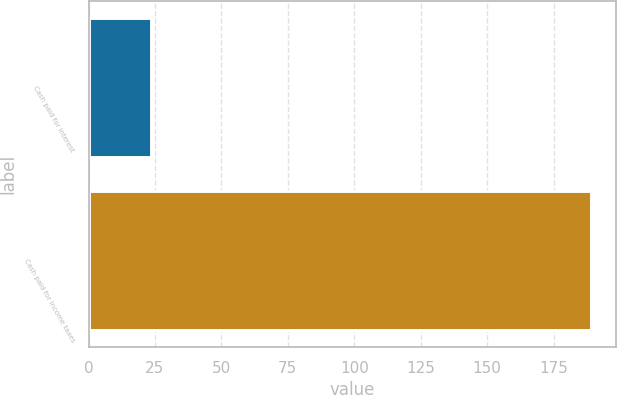Convert chart to OTSL. <chart><loc_0><loc_0><loc_500><loc_500><bar_chart><fcel>Cash paid for interest<fcel>Cash paid for income taxes<nl><fcel>23.6<fcel>189.2<nl></chart> 